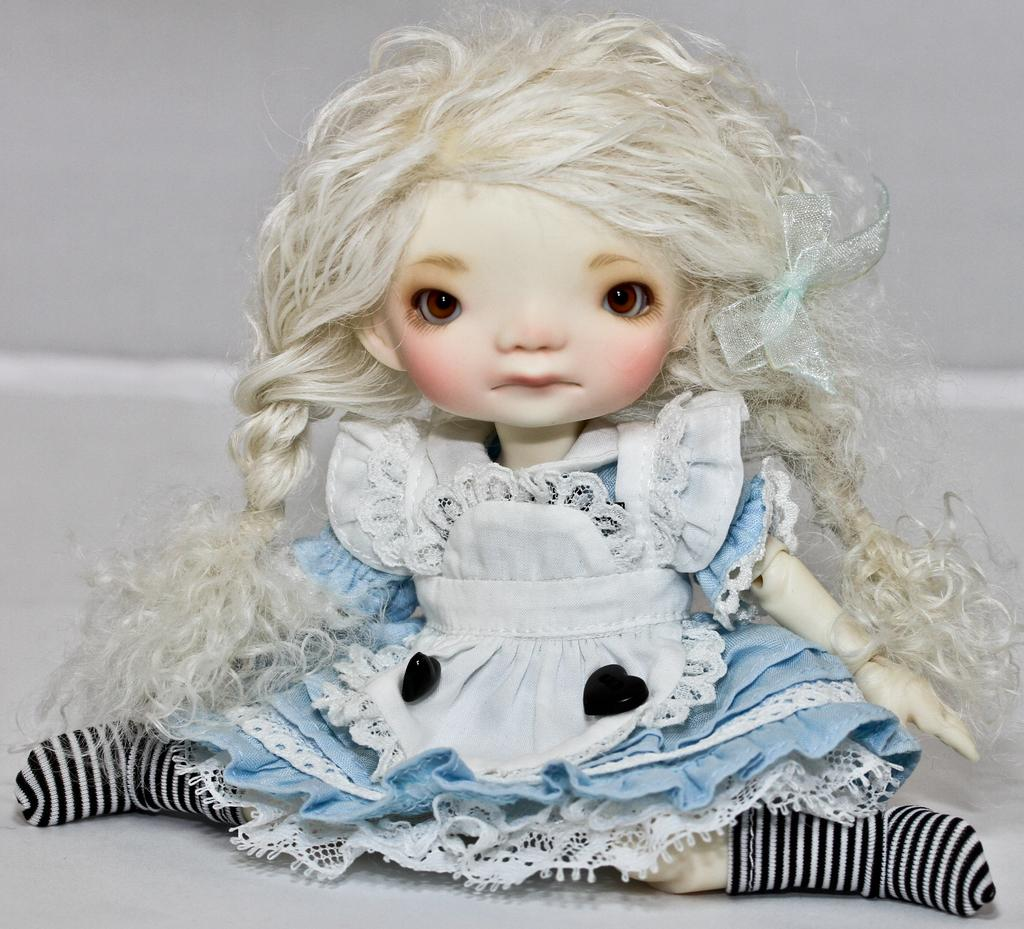What is the main subject in the middle of the image? There is a doll in the middle of the image. What is the color of the floor where the doll is placed? The doll is on a white floor. What can be observed about the doll's appearance? The doll has hair and is wearing a white and blue color frock with black and white lines socks. What is the color of the background in the image? The background of the image is white. Can you tell me how many oranges are on the doll's head in the image? There are no oranges present in the image, and therefore none can be observed on the doll's head. What type of lamp is visible in the image? There is no lamp present in the image. 